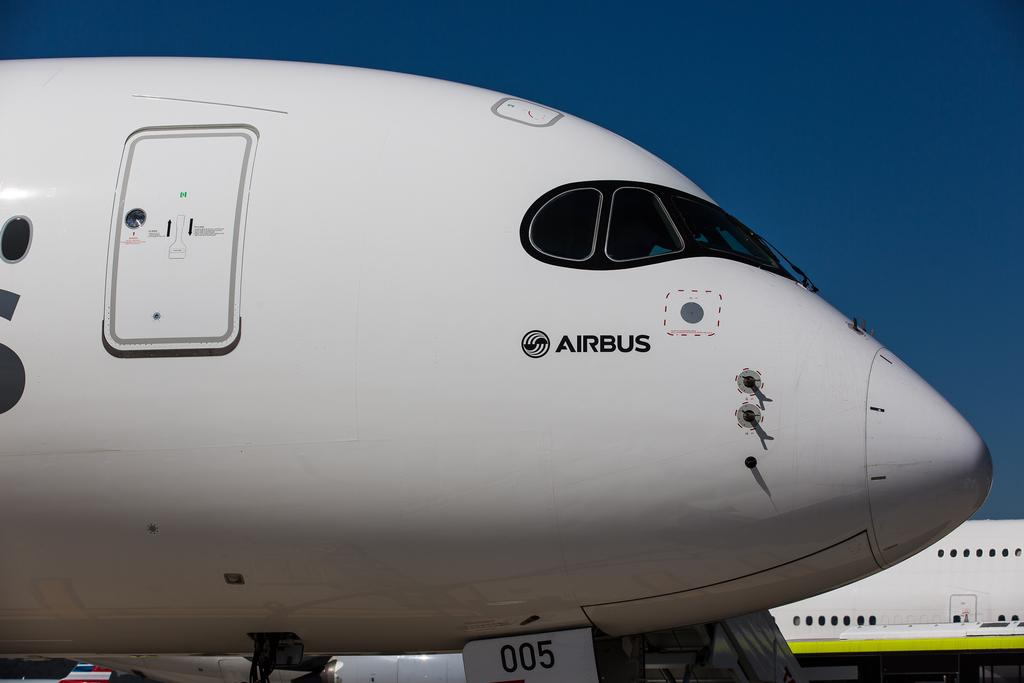<image>
Offer a succinct explanation of the picture presented. A large passenger plane with the word AIRBUS printed on the front. 